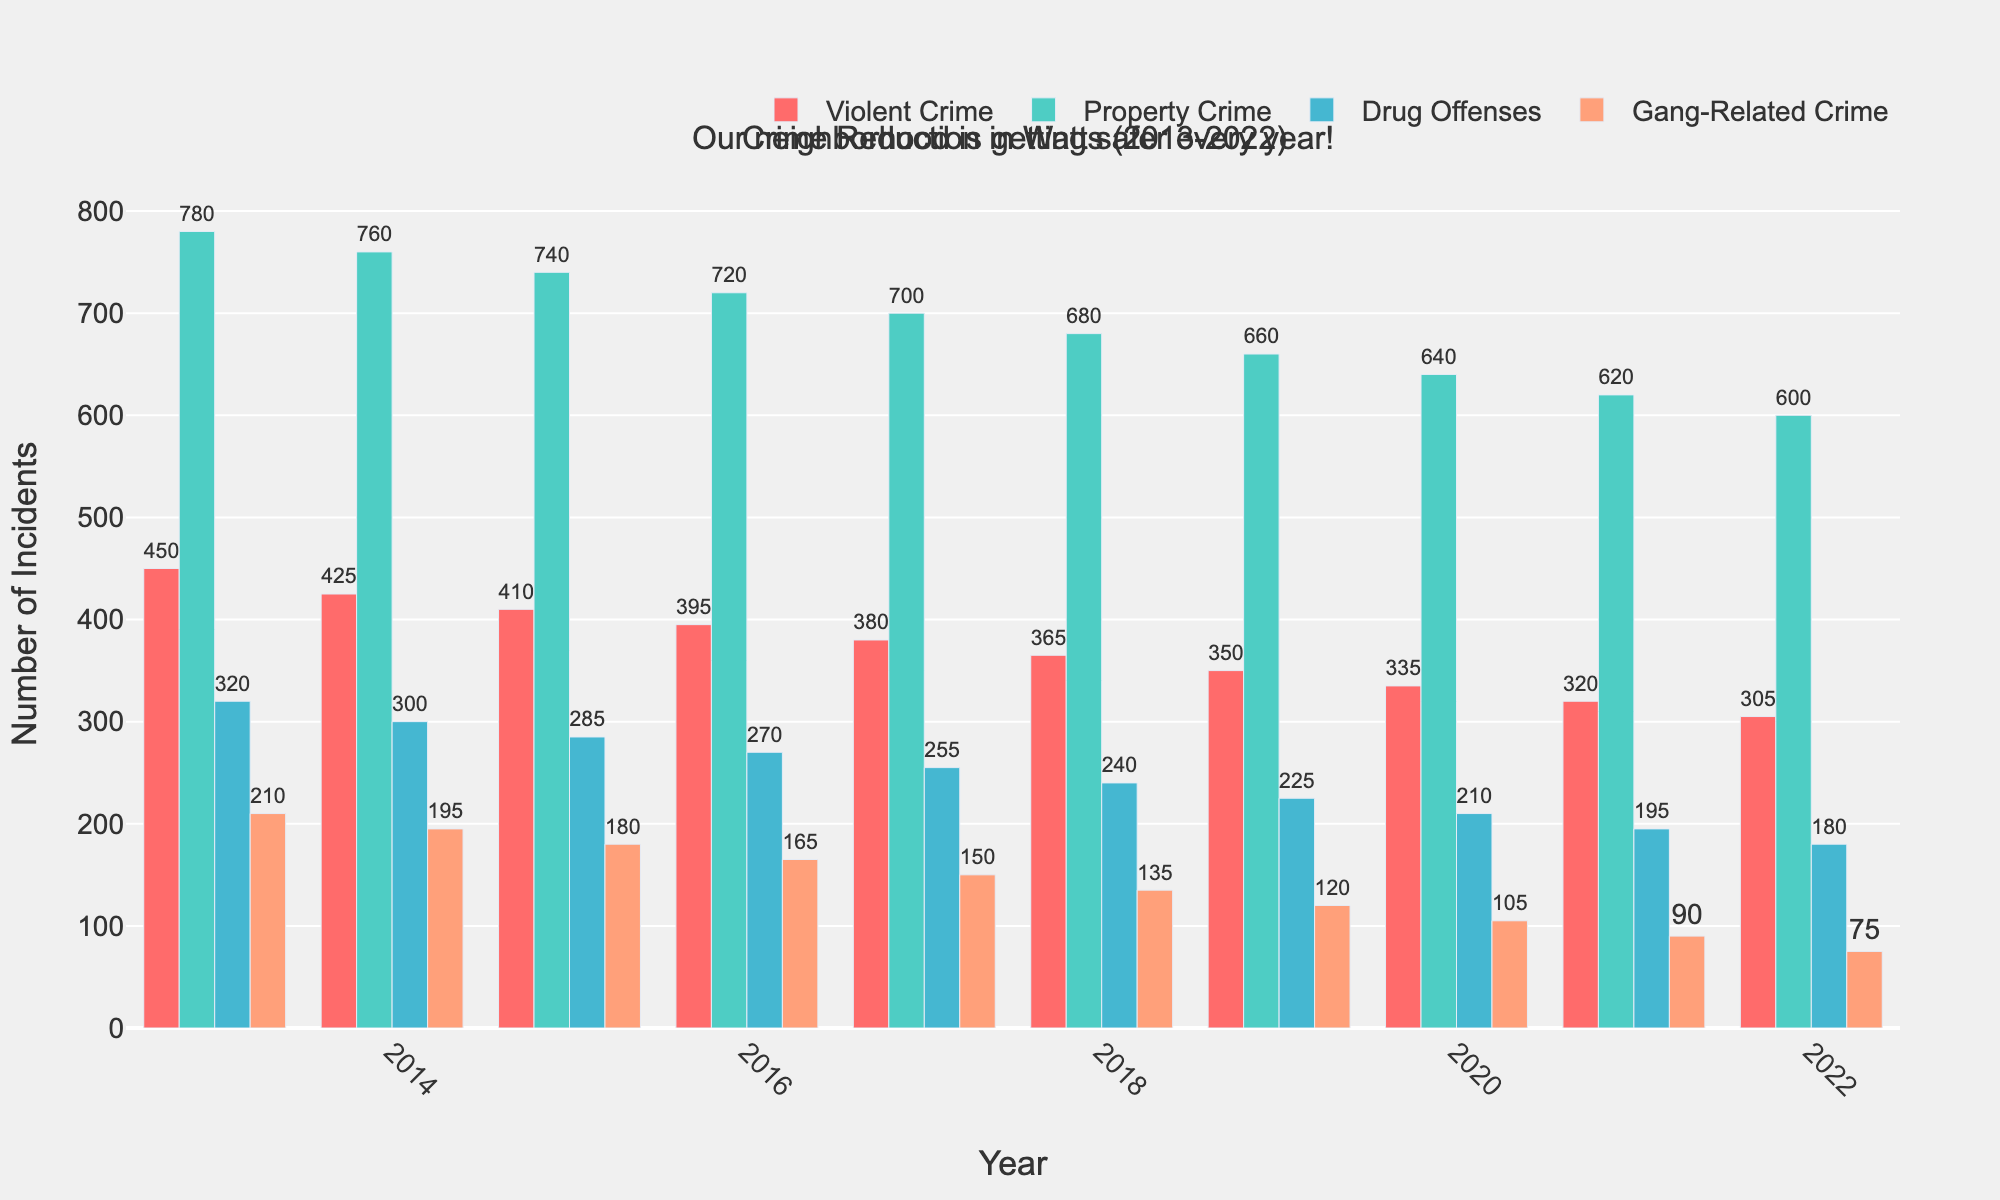What was the total reduction in Violent Crime from 2013 to 2022? First, find the value for Violent Crime in 2013, which is 450. Then, find the value in 2022, which is 305. Subtract the 2022 value from the 2013 value: 450 - 305 = 145
Answer: 145 Which type of crime saw the biggest drop between 2013 and 2022? Look at the first and last bars for each crime type and calculate the difference. Violent Crime: 450 - 305 = 145, Property Crime: 780 - 600 = 180, Drug Offenses: 320 - 180 = 140, Gang-Related Crime: 210 - 75 = 135. Property Crime saw the biggest drop at 180
Answer: Property Crime Was the reduction in Drug Offenses more or less than the reduction in Gang-Related Crime? Calculate the reductions: Drug Offenses: 320 - 180 = 140, Gang-Related Crime: 210 - 75 = 135. Compare the values, 140 is greater than 135, so Drug Offenses saw a greater reduction
Answer: More What is the average number of Property Crimes per year over this period? Add up all the Property Crime numbers from 2013 to 2022 (780 + 760 + 740 + 720 + 700 + 680 + 660 + 640 + 620 + 600) = 6900. Divide by the number of years (10): 6900 / 10 = 690
Answer: 690 Which year had the lowest number of Gang-Related Crimes? Look at the values for Gang-Related Crime for each year. The lowest value is in 2022 with 75
Answer: 2022 How much did Violent Crime decrease from 2016 to 2018? Find the values for 2016 and 2018: 2016 = 395, 2018 = 365. Subtract the 2018 value from the 2016 value: 395 - 365 = 30
Answer: 30 Between which consecutive years was the largest single-year drop in Property Crime recorded? Calculate the drop for each year: 
2013-2014: 780 - 760 = 20, 
2014-2015: 760 - 740 = 20,
2015-2016: 740 - 720 = 20,
2016-2017: 720 - 700 = 20,
2017-2018: 700 - 680 = 20,
2018-2019: 680 - 660 = 20,
2019-2020: 660 - 640 = 20,
2020-2021: 640 - 620 = 20,
2021-2022: 620 - 600 = 20. 
The drop is the same at 20 for each consecutive year. Therefore, between 2013-2014, 2014-2015, 2015-2016, 2016-2017, 2017-2018, 2018-2019, 2019-2020, 2020-2021, and 2021-2022 all saw the largest single-year drop in Property Crimes
Answer: 9 Consecutive years Which offense type was closest to experiencing a linear trend over the decade? Look at the slope of the bars for each type. The bars for Drug Offenses appear to decrease steadily without any notable variations, indicating a more linear trend
Answer: Drug Offenses 